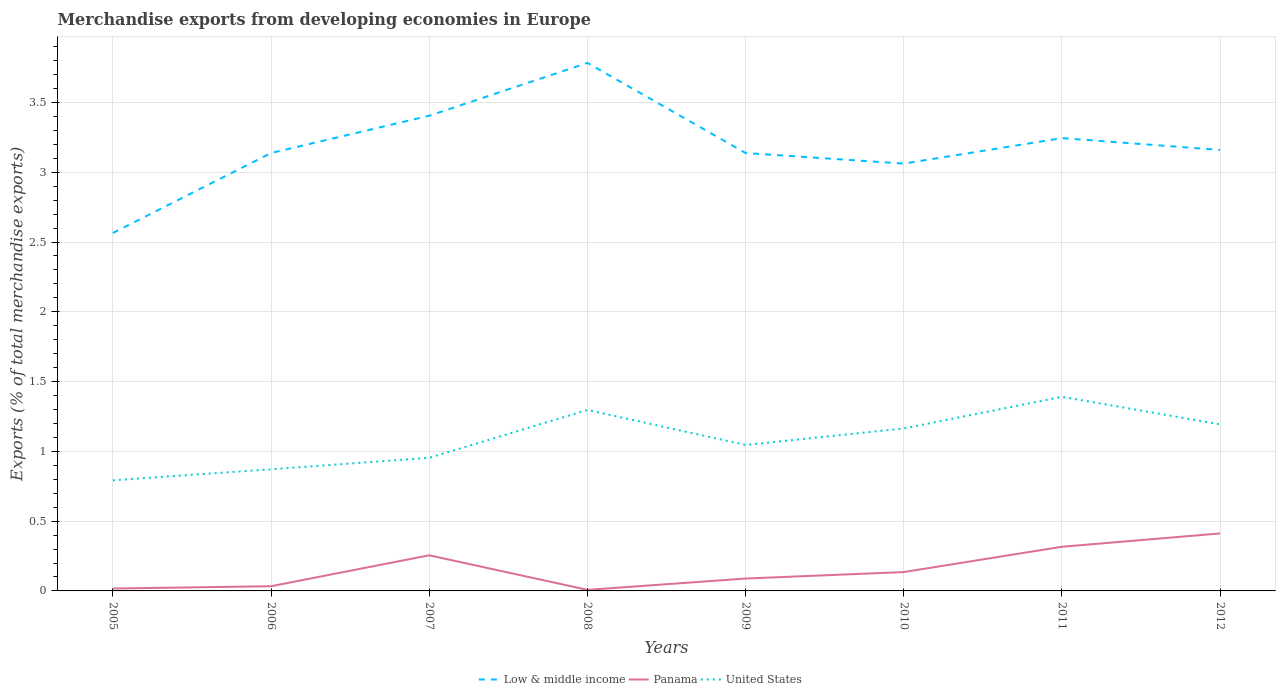How many different coloured lines are there?
Provide a short and direct response. 3. Does the line corresponding to Low & middle income intersect with the line corresponding to Panama?
Your response must be concise. No. Across all years, what is the maximum percentage of total merchandise exports in Low & middle income?
Provide a succinct answer. 2.56. What is the total percentage of total merchandise exports in United States in the graph?
Offer a terse response. -0.08. What is the difference between the highest and the second highest percentage of total merchandise exports in Panama?
Provide a succinct answer. 0.4. What is the difference between the highest and the lowest percentage of total merchandise exports in Low & middle income?
Provide a short and direct response. 3. How many years are there in the graph?
Offer a terse response. 8. Does the graph contain any zero values?
Give a very brief answer. No. Does the graph contain grids?
Your response must be concise. Yes. How many legend labels are there?
Give a very brief answer. 3. What is the title of the graph?
Offer a very short reply. Merchandise exports from developing economies in Europe. What is the label or title of the Y-axis?
Give a very brief answer. Exports (% of total merchandise exports). What is the Exports (% of total merchandise exports) in Low & middle income in 2005?
Give a very brief answer. 2.56. What is the Exports (% of total merchandise exports) in Panama in 2005?
Make the answer very short. 0.02. What is the Exports (% of total merchandise exports) in United States in 2005?
Your answer should be very brief. 0.79. What is the Exports (% of total merchandise exports) in Low & middle income in 2006?
Make the answer very short. 3.14. What is the Exports (% of total merchandise exports) in Panama in 2006?
Offer a terse response. 0.03. What is the Exports (% of total merchandise exports) in United States in 2006?
Provide a succinct answer. 0.87. What is the Exports (% of total merchandise exports) of Low & middle income in 2007?
Give a very brief answer. 3.4. What is the Exports (% of total merchandise exports) in Panama in 2007?
Give a very brief answer. 0.26. What is the Exports (% of total merchandise exports) of United States in 2007?
Your answer should be very brief. 0.95. What is the Exports (% of total merchandise exports) in Low & middle income in 2008?
Your response must be concise. 3.78. What is the Exports (% of total merchandise exports) of Panama in 2008?
Your answer should be compact. 0.01. What is the Exports (% of total merchandise exports) in United States in 2008?
Ensure brevity in your answer.  1.3. What is the Exports (% of total merchandise exports) of Low & middle income in 2009?
Ensure brevity in your answer.  3.14. What is the Exports (% of total merchandise exports) of Panama in 2009?
Give a very brief answer. 0.09. What is the Exports (% of total merchandise exports) in United States in 2009?
Offer a terse response. 1.05. What is the Exports (% of total merchandise exports) of Low & middle income in 2010?
Keep it short and to the point. 3.06. What is the Exports (% of total merchandise exports) in Panama in 2010?
Offer a very short reply. 0.14. What is the Exports (% of total merchandise exports) in United States in 2010?
Your answer should be compact. 1.16. What is the Exports (% of total merchandise exports) of Low & middle income in 2011?
Make the answer very short. 3.24. What is the Exports (% of total merchandise exports) of Panama in 2011?
Your answer should be very brief. 0.32. What is the Exports (% of total merchandise exports) of United States in 2011?
Provide a short and direct response. 1.39. What is the Exports (% of total merchandise exports) in Low & middle income in 2012?
Give a very brief answer. 3.16. What is the Exports (% of total merchandise exports) of Panama in 2012?
Your answer should be very brief. 0.41. What is the Exports (% of total merchandise exports) in United States in 2012?
Offer a terse response. 1.19. Across all years, what is the maximum Exports (% of total merchandise exports) of Low & middle income?
Provide a short and direct response. 3.78. Across all years, what is the maximum Exports (% of total merchandise exports) of Panama?
Offer a terse response. 0.41. Across all years, what is the maximum Exports (% of total merchandise exports) of United States?
Make the answer very short. 1.39. Across all years, what is the minimum Exports (% of total merchandise exports) in Low & middle income?
Provide a short and direct response. 2.56. Across all years, what is the minimum Exports (% of total merchandise exports) in Panama?
Provide a succinct answer. 0.01. Across all years, what is the minimum Exports (% of total merchandise exports) of United States?
Keep it short and to the point. 0.79. What is the total Exports (% of total merchandise exports) of Low & middle income in the graph?
Your answer should be compact. 25.49. What is the total Exports (% of total merchandise exports) of Panama in the graph?
Provide a succinct answer. 1.27. What is the total Exports (% of total merchandise exports) in United States in the graph?
Make the answer very short. 8.71. What is the difference between the Exports (% of total merchandise exports) in Low & middle income in 2005 and that in 2006?
Provide a succinct answer. -0.57. What is the difference between the Exports (% of total merchandise exports) in Panama in 2005 and that in 2006?
Give a very brief answer. -0.02. What is the difference between the Exports (% of total merchandise exports) in United States in 2005 and that in 2006?
Ensure brevity in your answer.  -0.08. What is the difference between the Exports (% of total merchandise exports) in Low & middle income in 2005 and that in 2007?
Provide a succinct answer. -0.84. What is the difference between the Exports (% of total merchandise exports) of Panama in 2005 and that in 2007?
Provide a succinct answer. -0.24. What is the difference between the Exports (% of total merchandise exports) in United States in 2005 and that in 2007?
Offer a very short reply. -0.16. What is the difference between the Exports (% of total merchandise exports) in Low & middle income in 2005 and that in 2008?
Offer a terse response. -1.22. What is the difference between the Exports (% of total merchandise exports) in Panama in 2005 and that in 2008?
Make the answer very short. 0.01. What is the difference between the Exports (% of total merchandise exports) in United States in 2005 and that in 2008?
Offer a very short reply. -0.5. What is the difference between the Exports (% of total merchandise exports) in Low & middle income in 2005 and that in 2009?
Keep it short and to the point. -0.57. What is the difference between the Exports (% of total merchandise exports) of Panama in 2005 and that in 2009?
Give a very brief answer. -0.07. What is the difference between the Exports (% of total merchandise exports) of United States in 2005 and that in 2009?
Keep it short and to the point. -0.25. What is the difference between the Exports (% of total merchandise exports) in Low & middle income in 2005 and that in 2010?
Make the answer very short. -0.5. What is the difference between the Exports (% of total merchandise exports) in Panama in 2005 and that in 2010?
Make the answer very short. -0.12. What is the difference between the Exports (% of total merchandise exports) of United States in 2005 and that in 2010?
Offer a very short reply. -0.37. What is the difference between the Exports (% of total merchandise exports) in Low & middle income in 2005 and that in 2011?
Make the answer very short. -0.68. What is the difference between the Exports (% of total merchandise exports) of Panama in 2005 and that in 2011?
Your response must be concise. -0.3. What is the difference between the Exports (% of total merchandise exports) in United States in 2005 and that in 2011?
Provide a short and direct response. -0.6. What is the difference between the Exports (% of total merchandise exports) in Low & middle income in 2005 and that in 2012?
Your answer should be compact. -0.59. What is the difference between the Exports (% of total merchandise exports) in Panama in 2005 and that in 2012?
Give a very brief answer. -0.39. What is the difference between the Exports (% of total merchandise exports) of United States in 2005 and that in 2012?
Offer a terse response. -0.4. What is the difference between the Exports (% of total merchandise exports) in Low & middle income in 2006 and that in 2007?
Provide a succinct answer. -0.27. What is the difference between the Exports (% of total merchandise exports) in Panama in 2006 and that in 2007?
Your response must be concise. -0.22. What is the difference between the Exports (% of total merchandise exports) of United States in 2006 and that in 2007?
Your answer should be compact. -0.08. What is the difference between the Exports (% of total merchandise exports) of Low & middle income in 2006 and that in 2008?
Your answer should be compact. -0.65. What is the difference between the Exports (% of total merchandise exports) in Panama in 2006 and that in 2008?
Your response must be concise. 0.03. What is the difference between the Exports (% of total merchandise exports) in United States in 2006 and that in 2008?
Make the answer very short. -0.42. What is the difference between the Exports (% of total merchandise exports) of Low & middle income in 2006 and that in 2009?
Your response must be concise. -0. What is the difference between the Exports (% of total merchandise exports) of Panama in 2006 and that in 2009?
Your answer should be very brief. -0.05. What is the difference between the Exports (% of total merchandise exports) of United States in 2006 and that in 2009?
Ensure brevity in your answer.  -0.17. What is the difference between the Exports (% of total merchandise exports) in Low & middle income in 2006 and that in 2010?
Make the answer very short. 0.08. What is the difference between the Exports (% of total merchandise exports) in Panama in 2006 and that in 2010?
Make the answer very short. -0.1. What is the difference between the Exports (% of total merchandise exports) in United States in 2006 and that in 2010?
Your answer should be compact. -0.29. What is the difference between the Exports (% of total merchandise exports) of Low & middle income in 2006 and that in 2011?
Your answer should be very brief. -0.11. What is the difference between the Exports (% of total merchandise exports) of Panama in 2006 and that in 2011?
Provide a succinct answer. -0.28. What is the difference between the Exports (% of total merchandise exports) of United States in 2006 and that in 2011?
Your answer should be very brief. -0.52. What is the difference between the Exports (% of total merchandise exports) in Low & middle income in 2006 and that in 2012?
Offer a terse response. -0.02. What is the difference between the Exports (% of total merchandise exports) in Panama in 2006 and that in 2012?
Your response must be concise. -0.38. What is the difference between the Exports (% of total merchandise exports) of United States in 2006 and that in 2012?
Ensure brevity in your answer.  -0.32. What is the difference between the Exports (% of total merchandise exports) in Low & middle income in 2007 and that in 2008?
Your response must be concise. -0.38. What is the difference between the Exports (% of total merchandise exports) in Panama in 2007 and that in 2008?
Provide a succinct answer. 0.25. What is the difference between the Exports (% of total merchandise exports) in United States in 2007 and that in 2008?
Give a very brief answer. -0.34. What is the difference between the Exports (% of total merchandise exports) in Low & middle income in 2007 and that in 2009?
Ensure brevity in your answer.  0.27. What is the difference between the Exports (% of total merchandise exports) of Panama in 2007 and that in 2009?
Provide a succinct answer. 0.17. What is the difference between the Exports (% of total merchandise exports) in United States in 2007 and that in 2009?
Offer a terse response. -0.09. What is the difference between the Exports (% of total merchandise exports) in Low & middle income in 2007 and that in 2010?
Give a very brief answer. 0.34. What is the difference between the Exports (% of total merchandise exports) of Panama in 2007 and that in 2010?
Provide a succinct answer. 0.12. What is the difference between the Exports (% of total merchandise exports) of United States in 2007 and that in 2010?
Your response must be concise. -0.21. What is the difference between the Exports (% of total merchandise exports) of Low & middle income in 2007 and that in 2011?
Offer a very short reply. 0.16. What is the difference between the Exports (% of total merchandise exports) of Panama in 2007 and that in 2011?
Offer a terse response. -0.06. What is the difference between the Exports (% of total merchandise exports) of United States in 2007 and that in 2011?
Offer a terse response. -0.44. What is the difference between the Exports (% of total merchandise exports) of Low & middle income in 2007 and that in 2012?
Provide a succinct answer. 0.24. What is the difference between the Exports (% of total merchandise exports) of Panama in 2007 and that in 2012?
Ensure brevity in your answer.  -0.16. What is the difference between the Exports (% of total merchandise exports) of United States in 2007 and that in 2012?
Your response must be concise. -0.24. What is the difference between the Exports (% of total merchandise exports) of Low & middle income in 2008 and that in 2009?
Ensure brevity in your answer.  0.65. What is the difference between the Exports (% of total merchandise exports) of Panama in 2008 and that in 2009?
Offer a very short reply. -0.08. What is the difference between the Exports (% of total merchandise exports) of United States in 2008 and that in 2009?
Provide a succinct answer. 0.25. What is the difference between the Exports (% of total merchandise exports) in Low & middle income in 2008 and that in 2010?
Offer a terse response. 0.72. What is the difference between the Exports (% of total merchandise exports) of Panama in 2008 and that in 2010?
Ensure brevity in your answer.  -0.13. What is the difference between the Exports (% of total merchandise exports) of United States in 2008 and that in 2010?
Your answer should be very brief. 0.13. What is the difference between the Exports (% of total merchandise exports) of Low & middle income in 2008 and that in 2011?
Your answer should be compact. 0.54. What is the difference between the Exports (% of total merchandise exports) of Panama in 2008 and that in 2011?
Provide a succinct answer. -0.31. What is the difference between the Exports (% of total merchandise exports) in United States in 2008 and that in 2011?
Keep it short and to the point. -0.09. What is the difference between the Exports (% of total merchandise exports) of Low & middle income in 2008 and that in 2012?
Make the answer very short. 0.62. What is the difference between the Exports (% of total merchandise exports) in Panama in 2008 and that in 2012?
Your response must be concise. -0.4. What is the difference between the Exports (% of total merchandise exports) in United States in 2008 and that in 2012?
Offer a terse response. 0.1. What is the difference between the Exports (% of total merchandise exports) in Low & middle income in 2009 and that in 2010?
Provide a short and direct response. 0.08. What is the difference between the Exports (% of total merchandise exports) of Panama in 2009 and that in 2010?
Your answer should be very brief. -0.05. What is the difference between the Exports (% of total merchandise exports) of United States in 2009 and that in 2010?
Your answer should be very brief. -0.12. What is the difference between the Exports (% of total merchandise exports) of Low & middle income in 2009 and that in 2011?
Provide a short and direct response. -0.11. What is the difference between the Exports (% of total merchandise exports) of Panama in 2009 and that in 2011?
Offer a terse response. -0.23. What is the difference between the Exports (% of total merchandise exports) in United States in 2009 and that in 2011?
Provide a short and direct response. -0.35. What is the difference between the Exports (% of total merchandise exports) in Low & middle income in 2009 and that in 2012?
Provide a short and direct response. -0.02. What is the difference between the Exports (% of total merchandise exports) of Panama in 2009 and that in 2012?
Offer a very short reply. -0.32. What is the difference between the Exports (% of total merchandise exports) of United States in 2009 and that in 2012?
Your answer should be compact. -0.15. What is the difference between the Exports (% of total merchandise exports) of Low & middle income in 2010 and that in 2011?
Your answer should be compact. -0.18. What is the difference between the Exports (% of total merchandise exports) of Panama in 2010 and that in 2011?
Ensure brevity in your answer.  -0.18. What is the difference between the Exports (% of total merchandise exports) of United States in 2010 and that in 2011?
Give a very brief answer. -0.23. What is the difference between the Exports (% of total merchandise exports) of Low & middle income in 2010 and that in 2012?
Provide a succinct answer. -0.1. What is the difference between the Exports (% of total merchandise exports) in Panama in 2010 and that in 2012?
Your response must be concise. -0.28. What is the difference between the Exports (% of total merchandise exports) in United States in 2010 and that in 2012?
Give a very brief answer. -0.03. What is the difference between the Exports (% of total merchandise exports) of Low & middle income in 2011 and that in 2012?
Make the answer very short. 0.08. What is the difference between the Exports (% of total merchandise exports) in Panama in 2011 and that in 2012?
Provide a succinct answer. -0.1. What is the difference between the Exports (% of total merchandise exports) in United States in 2011 and that in 2012?
Give a very brief answer. 0.2. What is the difference between the Exports (% of total merchandise exports) of Low & middle income in 2005 and the Exports (% of total merchandise exports) of Panama in 2006?
Your response must be concise. 2.53. What is the difference between the Exports (% of total merchandise exports) in Low & middle income in 2005 and the Exports (% of total merchandise exports) in United States in 2006?
Ensure brevity in your answer.  1.69. What is the difference between the Exports (% of total merchandise exports) in Panama in 2005 and the Exports (% of total merchandise exports) in United States in 2006?
Provide a succinct answer. -0.85. What is the difference between the Exports (% of total merchandise exports) of Low & middle income in 2005 and the Exports (% of total merchandise exports) of Panama in 2007?
Offer a terse response. 2.31. What is the difference between the Exports (% of total merchandise exports) in Low & middle income in 2005 and the Exports (% of total merchandise exports) in United States in 2007?
Offer a terse response. 1.61. What is the difference between the Exports (% of total merchandise exports) of Panama in 2005 and the Exports (% of total merchandise exports) of United States in 2007?
Your answer should be compact. -0.94. What is the difference between the Exports (% of total merchandise exports) of Low & middle income in 2005 and the Exports (% of total merchandise exports) of Panama in 2008?
Offer a terse response. 2.56. What is the difference between the Exports (% of total merchandise exports) of Low & middle income in 2005 and the Exports (% of total merchandise exports) of United States in 2008?
Provide a short and direct response. 1.27. What is the difference between the Exports (% of total merchandise exports) of Panama in 2005 and the Exports (% of total merchandise exports) of United States in 2008?
Offer a terse response. -1.28. What is the difference between the Exports (% of total merchandise exports) in Low & middle income in 2005 and the Exports (% of total merchandise exports) in Panama in 2009?
Your answer should be compact. 2.48. What is the difference between the Exports (% of total merchandise exports) in Low & middle income in 2005 and the Exports (% of total merchandise exports) in United States in 2009?
Offer a terse response. 1.52. What is the difference between the Exports (% of total merchandise exports) in Panama in 2005 and the Exports (% of total merchandise exports) in United States in 2009?
Offer a very short reply. -1.03. What is the difference between the Exports (% of total merchandise exports) in Low & middle income in 2005 and the Exports (% of total merchandise exports) in Panama in 2010?
Ensure brevity in your answer.  2.43. What is the difference between the Exports (% of total merchandise exports) in Low & middle income in 2005 and the Exports (% of total merchandise exports) in United States in 2010?
Provide a short and direct response. 1.4. What is the difference between the Exports (% of total merchandise exports) in Panama in 2005 and the Exports (% of total merchandise exports) in United States in 2010?
Your answer should be very brief. -1.15. What is the difference between the Exports (% of total merchandise exports) in Low & middle income in 2005 and the Exports (% of total merchandise exports) in Panama in 2011?
Offer a terse response. 2.25. What is the difference between the Exports (% of total merchandise exports) in Low & middle income in 2005 and the Exports (% of total merchandise exports) in United States in 2011?
Ensure brevity in your answer.  1.17. What is the difference between the Exports (% of total merchandise exports) of Panama in 2005 and the Exports (% of total merchandise exports) of United States in 2011?
Provide a succinct answer. -1.37. What is the difference between the Exports (% of total merchandise exports) of Low & middle income in 2005 and the Exports (% of total merchandise exports) of Panama in 2012?
Your answer should be very brief. 2.15. What is the difference between the Exports (% of total merchandise exports) of Low & middle income in 2005 and the Exports (% of total merchandise exports) of United States in 2012?
Give a very brief answer. 1.37. What is the difference between the Exports (% of total merchandise exports) of Panama in 2005 and the Exports (% of total merchandise exports) of United States in 2012?
Keep it short and to the point. -1.18. What is the difference between the Exports (% of total merchandise exports) in Low & middle income in 2006 and the Exports (% of total merchandise exports) in Panama in 2007?
Give a very brief answer. 2.88. What is the difference between the Exports (% of total merchandise exports) of Low & middle income in 2006 and the Exports (% of total merchandise exports) of United States in 2007?
Your response must be concise. 2.18. What is the difference between the Exports (% of total merchandise exports) in Panama in 2006 and the Exports (% of total merchandise exports) in United States in 2007?
Your answer should be compact. -0.92. What is the difference between the Exports (% of total merchandise exports) in Low & middle income in 2006 and the Exports (% of total merchandise exports) in Panama in 2008?
Give a very brief answer. 3.13. What is the difference between the Exports (% of total merchandise exports) in Low & middle income in 2006 and the Exports (% of total merchandise exports) in United States in 2008?
Provide a short and direct response. 1.84. What is the difference between the Exports (% of total merchandise exports) in Panama in 2006 and the Exports (% of total merchandise exports) in United States in 2008?
Offer a very short reply. -1.26. What is the difference between the Exports (% of total merchandise exports) in Low & middle income in 2006 and the Exports (% of total merchandise exports) in Panama in 2009?
Your response must be concise. 3.05. What is the difference between the Exports (% of total merchandise exports) in Low & middle income in 2006 and the Exports (% of total merchandise exports) in United States in 2009?
Make the answer very short. 2.09. What is the difference between the Exports (% of total merchandise exports) in Panama in 2006 and the Exports (% of total merchandise exports) in United States in 2009?
Your answer should be compact. -1.01. What is the difference between the Exports (% of total merchandise exports) in Low & middle income in 2006 and the Exports (% of total merchandise exports) in Panama in 2010?
Your answer should be very brief. 3. What is the difference between the Exports (% of total merchandise exports) in Low & middle income in 2006 and the Exports (% of total merchandise exports) in United States in 2010?
Your answer should be very brief. 1.97. What is the difference between the Exports (% of total merchandise exports) of Panama in 2006 and the Exports (% of total merchandise exports) of United States in 2010?
Your answer should be very brief. -1.13. What is the difference between the Exports (% of total merchandise exports) of Low & middle income in 2006 and the Exports (% of total merchandise exports) of Panama in 2011?
Offer a very short reply. 2.82. What is the difference between the Exports (% of total merchandise exports) of Low & middle income in 2006 and the Exports (% of total merchandise exports) of United States in 2011?
Offer a terse response. 1.75. What is the difference between the Exports (% of total merchandise exports) of Panama in 2006 and the Exports (% of total merchandise exports) of United States in 2011?
Give a very brief answer. -1.36. What is the difference between the Exports (% of total merchandise exports) of Low & middle income in 2006 and the Exports (% of total merchandise exports) of Panama in 2012?
Offer a terse response. 2.73. What is the difference between the Exports (% of total merchandise exports) in Low & middle income in 2006 and the Exports (% of total merchandise exports) in United States in 2012?
Provide a short and direct response. 1.94. What is the difference between the Exports (% of total merchandise exports) of Panama in 2006 and the Exports (% of total merchandise exports) of United States in 2012?
Provide a succinct answer. -1.16. What is the difference between the Exports (% of total merchandise exports) of Low & middle income in 2007 and the Exports (% of total merchandise exports) of Panama in 2008?
Offer a terse response. 3.4. What is the difference between the Exports (% of total merchandise exports) in Low & middle income in 2007 and the Exports (% of total merchandise exports) in United States in 2008?
Make the answer very short. 2.11. What is the difference between the Exports (% of total merchandise exports) in Panama in 2007 and the Exports (% of total merchandise exports) in United States in 2008?
Keep it short and to the point. -1.04. What is the difference between the Exports (% of total merchandise exports) in Low & middle income in 2007 and the Exports (% of total merchandise exports) in Panama in 2009?
Your answer should be compact. 3.32. What is the difference between the Exports (% of total merchandise exports) of Low & middle income in 2007 and the Exports (% of total merchandise exports) of United States in 2009?
Your response must be concise. 2.36. What is the difference between the Exports (% of total merchandise exports) in Panama in 2007 and the Exports (% of total merchandise exports) in United States in 2009?
Your answer should be compact. -0.79. What is the difference between the Exports (% of total merchandise exports) of Low & middle income in 2007 and the Exports (% of total merchandise exports) of Panama in 2010?
Provide a short and direct response. 3.27. What is the difference between the Exports (% of total merchandise exports) of Low & middle income in 2007 and the Exports (% of total merchandise exports) of United States in 2010?
Give a very brief answer. 2.24. What is the difference between the Exports (% of total merchandise exports) in Panama in 2007 and the Exports (% of total merchandise exports) in United States in 2010?
Offer a very short reply. -0.91. What is the difference between the Exports (% of total merchandise exports) of Low & middle income in 2007 and the Exports (% of total merchandise exports) of Panama in 2011?
Your answer should be very brief. 3.09. What is the difference between the Exports (% of total merchandise exports) in Low & middle income in 2007 and the Exports (% of total merchandise exports) in United States in 2011?
Keep it short and to the point. 2.01. What is the difference between the Exports (% of total merchandise exports) in Panama in 2007 and the Exports (% of total merchandise exports) in United States in 2011?
Offer a terse response. -1.14. What is the difference between the Exports (% of total merchandise exports) in Low & middle income in 2007 and the Exports (% of total merchandise exports) in Panama in 2012?
Your answer should be very brief. 2.99. What is the difference between the Exports (% of total merchandise exports) of Low & middle income in 2007 and the Exports (% of total merchandise exports) of United States in 2012?
Give a very brief answer. 2.21. What is the difference between the Exports (% of total merchandise exports) in Panama in 2007 and the Exports (% of total merchandise exports) in United States in 2012?
Your answer should be compact. -0.94. What is the difference between the Exports (% of total merchandise exports) in Low & middle income in 2008 and the Exports (% of total merchandise exports) in Panama in 2009?
Provide a succinct answer. 3.69. What is the difference between the Exports (% of total merchandise exports) in Low & middle income in 2008 and the Exports (% of total merchandise exports) in United States in 2009?
Offer a very short reply. 2.74. What is the difference between the Exports (% of total merchandise exports) of Panama in 2008 and the Exports (% of total merchandise exports) of United States in 2009?
Offer a very short reply. -1.04. What is the difference between the Exports (% of total merchandise exports) in Low & middle income in 2008 and the Exports (% of total merchandise exports) in Panama in 2010?
Offer a very short reply. 3.65. What is the difference between the Exports (% of total merchandise exports) in Low & middle income in 2008 and the Exports (% of total merchandise exports) in United States in 2010?
Your answer should be very brief. 2.62. What is the difference between the Exports (% of total merchandise exports) of Panama in 2008 and the Exports (% of total merchandise exports) of United States in 2010?
Your answer should be very brief. -1.16. What is the difference between the Exports (% of total merchandise exports) in Low & middle income in 2008 and the Exports (% of total merchandise exports) in Panama in 2011?
Offer a terse response. 3.47. What is the difference between the Exports (% of total merchandise exports) of Low & middle income in 2008 and the Exports (% of total merchandise exports) of United States in 2011?
Make the answer very short. 2.39. What is the difference between the Exports (% of total merchandise exports) in Panama in 2008 and the Exports (% of total merchandise exports) in United States in 2011?
Ensure brevity in your answer.  -1.38. What is the difference between the Exports (% of total merchandise exports) in Low & middle income in 2008 and the Exports (% of total merchandise exports) in Panama in 2012?
Your answer should be compact. 3.37. What is the difference between the Exports (% of total merchandise exports) of Low & middle income in 2008 and the Exports (% of total merchandise exports) of United States in 2012?
Your answer should be compact. 2.59. What is the difference between the Exports (% of total merchandise exports) in Panama in 2008 and the Exports (% of total merchandise exports) in United States in 2012?
Your answer should be compact. -1.19. What is the difference between the Exports (% of total merchandise exports) in Low & middle income in 2009 and the Exports (% of total merchandise exports) in Panama in 2010?
Your response must be concise. 3. What is the difference between the Exports (% of total merchandise exports) in Low & middle income in 2009 and the Exports (% of total merchandise exports) in United States in 2010?
Give a very brief answer. 1.97. What is the difference between the Exports (% of total merchandise exports) in Panama in 2009 and the Exports (% of total merchandise exports) in United States in 2010?
Offer a terse response. -1.08. What is the difference between the Exports (% of total merchandise exports) of Low & middle income in 2009 and the Exports (% of total merchandise exports) of Panama in 2011?
Offer a very short reply. 2.82. What is the difference between the Exports (% of total merchandise exports) of Low & middle income in 2009 and the Exports (% of total merchandise exports) of United States in 2011?
Provide a succinct answer. 1.75. What is the difference between the Exports (% of total merchandise exports) of Panama in 2009 and the Exports (% of total merchandise exports) of United States in 2011?
Provide a short and direct response. -1.3. What is the difference between the Exports (% of total merchandise exports) of Low & middle income in 2009 and the Exports (% of total merchandise exports) of Panama in 2012?
Ensure brevity in your answer.  2.73. What is the difference between the Exports (% of total merchandise exports) of Low & middle income in 2009 and the Exports (% of total merchandise exports) of United States in 2012?
Keep it short and to the point. 1.94. What is the difference between the Exports (% of total merchandise exports) in Panama in 2009 and the Exports (% of total merchandise exports) in United States in 2012?
Provide a short and direct response. -1.1. What is the difference between the Exports (% of total merchandise exports) in Low & middle income in 2010 and the Exports (% of total merchandise exports) in Panama in 2011?
Make the answer very short. 2.75. What is the difference between the Exports (% of total merchandise exports) of Low & middle income in 2010 and the Exports (% of total merchandise exports) of United States in 2011?
Provide a short and direct response. 1.67. What is the difference between the Exports (% of total merchandise exports) of Panama in 2010 and the Exports (% of total merchandise exports) of United States in 2011?
Keep it short and to the point. -1.26. What is the difference between the Exports (% of total merchandise exports) in Low & middle income in 2010 and the Exports (% of total merchandise exports) in Panama in 2012?
Ensure brevity in your answer.  2.65. What is the difference between the Exports (% of total merchandise exports) of Low & middle income in 2010 and the Exports (% of total merchandise exports) of United States in 2012?
Offer a very short reply. 1.87. What is the difference between the Exports (% of total merchandise exports) in Panama in 2010 and the Exports (% of total merchandise exports) in United States in 2012?
Keep it short and to the point. -1.06. What is the difference between the Exports (% of total merchandise exports) in Low & middle income in 2011 and the Exports (% of total merchandise exports) in Panama in 2012?
Provide a succinct answer. 2.83. What is the difference between the Exports (% of total merchandise exports) in Low & middle income in 2011 and the Exports (% of total merchandise exports) in United States in 2012?
Provide a short and direct response. 2.05. What is the difference between the Exports (% of total merchandise exports) in Panama in 2011 and the Exports (% of total merchandise exports) in United States in 2012?
Ensure brevity in your answer.  -0.88. What is the average Exports (% of total merchandise exports) in Low & middle income per year?
Your answer should be very brief. 3.19. What is the average Exports (% of total merchandise exports) in Panama per year?
Offer a very short reply. 0.16. What is the average Exports (% of total merchandise exports) of United States per year?
Offer a terse response. 1.09. In the year 2005, what is the difference between the Exports (% of total merchandise exports) in Low & middle income and Exports (% of total merchandise exports) in Panama?
Keep it short and to the point. 2.55. In the year 2005, what is the difference between the Exports (% of total merchandise exports) in Low & middle income and Exports (% of total merchandise exports) in United States?
Make the answer very short. 1.77. In the year 2005, what is the difference between the Exports (% of total merchandise exports) of Panama and Exports (% of total merchandise exports) of United States?
Your answer should be very brief. -0.78. In the year 2006, what is the difference between the Exports (% of total merchandise exports) of Low & middle income and Exports (% of total merchandise exports) of Panama?
Your answer should be compact. 3.1. In the year 2006, what is the difference between the Exports (% of total merchandise exports) of Low & middle income and Exports (% of total merchandise exports) of United States?
Give a very brief answer. 2.27. In the year 2006, what is the difference between the Exports (% of total merchandise exports) of Panama and Exports (% of total merchandise exports) of United States?
Offer a terse response. -0.84. In the year 2007, what is the difference between the Exports (% of total merchandise exports) in Low & middle income and Exports (% of total merchandise exports) in Panama?
Ensure brevity in your answer.  3.15. In the year 2007, what is the difference between the Exports (% of total merchandise exports) of Low & middle income and Exports (% of total merchandise exports) of United States?
Keep it short and to the point. 2.45. In the year 2007, what is the difference between the Exports (% of total merchandise exports) of Panama and Exports (% of total merchandise exports) of United States?
Ensure brevity in your answer.  -0.7. In the year 2008, what is the difference between the Exports (% of total merchandise exports) in Low & middle income and Exports (% of total merchandise exports) in Panama?
Provide a short and direct response. 3.78. In the year 2008, what is the difference between the Exports (% of total merchandise exports) in Low & middle income and Exports (% of total merchandise exports) in United States?
Your answer should be compact. 2.49. In the year 2008, what is the difference between the Exports (% of total merchandise exports) of Panama and Exports (% of total merchandise exports) of United States?
Your response must be concise. -1.29. In the year 2009, what is the difference between the Exports (% of total merchandise exports) of Low & middle income and Exports (% of total merchandise exports) of Panama?
Keep it short and to the point. 3.05. In the year 2009, what is the difference between the Exports (% of total merchandise exports) in Low & middle income and Exports (% of total merchandise exports) in United States?
Ensure brevity in your answer.  2.09. In the year 2009, what is the difference between the Exports (% of total merchandise exports) of Panama and Exports (% of total merchandise exports) of United States?
Give a very brief answer. -0.96. In the year 2010, what is the difference between the Exports (% of total merchandise exports) in Low & middle income and Exports (% of total merchandise exports) in Panama?
Give a very brief answer. 2.93. In the year 2010, what is the difference between the Exports (% of total merchandise exports) in Low & middle income and Exports (% of total merchandise exports) in United States?
Make the answer very short. 1.9. In the year 2010, what is the difference between the Exports (% of total merchandise exports) of Panama and Exports (% of total merchandise exports) of United States?
Offer a very short reply. -1.03. In the year 2011, what is the difference between the Exports (% of total merchandise exports) of Low & middle income and Exports (% of total merchandise exports) of Panama?
Your answer should be very brief. 2.93. In the year 2011, what is the difference between the Exports (% of total merchandise exports) in Low & middle income and Exports (% of total merchandise exports) in United States?
Make the answer very short. 1.85. In the year 2011, what is the difference between the Exports (% of total merchandise exports) of Panama and Exports (% of total merchandise exports) of United States?
Provide a succinct answer. -1.07. In the year 2012, what is the difference between the Exports (% of total merchandise exports) in Low & middle income and Exports (% of total merchandise exports) in Panama?
Provide a succinct answer. 2.75. In the year 2012, what is the difference between the Exports (% of total merchandise exports) in Low & middle income and Exports (% of total merchandise exports) in United States?
Ensure brevity in your answer.  1.97. In the year 2012, what is the difference between the Exports (% of total merchandise exports) of Panama and Exports (% of total merchandise exports) of United States?
Offer a terse response. -0.78. What is the ratio of the Exports (% of total merchandise exports) in Low & middle income in 2005 to that in 2006?
Keep it short and to the point. 0.82. What is the ratio of the Exports (% of total merchandise exports) of Panama in 2005 to that in 2006?
Give a very brief answer. 0.51. What is the ratio of the Exports (% of total merchandise exports) of United States in 2005 to that in 2006?
Your response must be concise. 0.91. What is the ratio of the Exports (% of total merchandise exports) in Low & middle income in 2005 to that in 2007?
Your answer should be very brief. 0.75. What is the ratio of the Exports (% of total merchandise exports) of Panama in 2005 to that in 2007?
Your response must be concise. 0.07. What is the ratio of the Exports (% of total merchandise exports) in United States in 2005 to that in 2007?
Ensure brevity in your answer.  0.83. What is the ratio of the Exports (% of total merchandise exports) in Low & middle income in 2005 to that in 2008?
Offer a very short reply. 0.68. What is the ratio of the Exports (% of total merchandise exports) of Panama in 2005 to that in 2008?
Give a very brief answer. 2.24. What is the ratio of the Exports (% of total merchandise exports) of United States in 2005 to that in 2008?
Your answer should be very brief. 0.61. What is the ratio of the Exports (% of total merchandise exports) of Low & middle income in 2005 to that in 2009?
Provide a short and direct response. 0.82. What is the ratio of the Exports (% of total merchandise exports) in Panama in 2005 to that in 2009?
Ensure brevity in your answer.  0.19. What is the ratio of the Exports (% of total merchandise exports) in United States in 2005 to that in 2009?
Keep it short and to the point. 0.76. What is the ratio of the Exports (% of total merchandise exports) in Low & middle income in 2005 to that in 2010?
Your answer should be very brief. 0.84. What is the ratio of the Exports (% of total merchandise exports) in Panama in 2005 to that in 2010?
Make the answer very short. 0.13. What is the ratio of the Exports (% of total merchandise exports) in United States in 2005 to that in 2010?
Ensure brevity in your answer.  0.68. What is the ratio of the Exports (% of total merchandise exports) in Low & middle income in 2005 to that in 2011?
Give a very brief answer. 0.79. What is the ratio of the Exports (% of total merchandise exports) in Panama in 2005 to that in 2011?
Offer a very short reply. 0.05. What is the ratio of the Exports (% of total merchandise exports) of United States in 2005 to that in 2011?
Provide a succinct answer. 0.57. What is the ratio of the Exports (% of total merchandise exports) of Low & middle income in 2005 to that in 2012?
Provide a succinct answer. 0.81. What is the ratio of the Exports (% of total merchandise exports) of Panama in 2005 to that in 2012?
Your answer should be very brief. 0.04. What is the ratio of the Exports (% of total merchandise exports) of United States in 2005 to that in 2012?
Make the answer very short. 0.66. What is the ratio of the Exports (% of total merchandise exports) of Low & middle income in 2006 to that in 2007?
Ensure brevity in your answer.  0.92. What is the ratio of the Exports (% of total merchandise exports) in Panama in 2006 to that in 2007?
Ensure brevity in your answer.  0.13. What is the ratio of the Exports (% of total merchandise exports) in United States in 2006 to that in 2007?
Your answer should be compact. 0.91. What is the ratio of the Exports (% of total merchandise exports) of Low & middle income in 2006 to that in 2008?
Offer a very short reply. 0.83. What is the ratio of the Exports (% of total merchandise exports) in Panama in 2006 to that in 2008?
Your answer should be compact. 4.42. What is the ratio of the Exports (% of total merchandise exports) of United States in 2006 to that in 2008?
Provide a short and direct response. 0.67. What is the ratio of the Exports (% of total merchandise exports) of Low & middle income in 2006 to that in 2009?
Your answer should be very brief. 1. What is the ratio of the Exports (% of total merchandise exports) of Panama in 2006 to that in 2009?
Give a very brief answer. 0.38. What is the ratio of the Exports (% of total merchandise exports) in United States in 2006 to that in 2009?
Give a very brief answer. 0.83. What is the ratio of the Exports (% of total merchandise exports) in Low & middle income in 2006 to that in 2010?
Offer a very short reply. 1.02. What is the ratio of the Exports (% of total merchandise exports) of Panama in 2006 to that in 2010?
Your answer should be compact. 0.25. What is the ratio of the Exports (% of total merchandise exports) in United States in 2006 to that in 2010?
Your answer should be compact. 0.75. What is the ratio of the Exports (% of total merchandise exports) in Low & middle income in 2006 to that in 2011?
Give a very brief answer. 0.97. What is the ratio of the Exports (% of total merchandise exports) of Panama in 2006 to that in 2011?
Your response must be concise. 0.11. What is the ratio of the Exports (% of total merchandise exports) of United States in 2006 to that in 2011?
Provide a succinct answer. 0.63. What is the ratio of the Exports (% of total merchandise exports) of Low & middle income in 2006 to that in 2012?
Your response must be concise. 0.99. What is the ratio of the Exports (% of total merchandise exports) in Panama in 2006 to that in 2012?
Your answer should be compact. 0.08. What is the ratio of the Exports (% of total merchandise exports) of United States in 2006 to that in 2012?
Provide a short and direct response. 0.73. What is the ratio of the Exports (% of total merchandise exports) of Panama in 2007 to that in 2008?
Offer a very short reply. 33.42. What is the ratio of the Exports (% of total merchandise exports) in United States in 2007 to that in 2008?
Provide a succinct answer. 0.74. What is the ratio of the Exports (% of total merchandise exports) in Low & middle income in 2007 to that in 2009?
Your answer should be very brief. 1.09. What is the ratio of the Exports (% of total merchandise exports) in Panama in 2007 to that in 2009?
Your answer should be very brief. 2.88. What is the ratio of the Exports (% of total merchandise exports) in United States in 2007 to that in 2009?
Offer a terse response. 0.91. What is the ratio of the Exports (% of total merchandise exports) of Low & middle income in 2007 to that in 2010?
Offer a terse response. 1.11. What is the ratio of the Exports (% of total merchandise exports) in Panama in 2007 to that in 2010?
Provide a succinct answer. 1.89. What is the ratio of the Exports (% of total merchandise exports) of United States in 2007 to that in 2010?
Keep it short and to the point. 0.82. What is the ratio of the Exports (% of total merchandise exports) in Low & middle income in 2007 to that in 2011?
Provide a succinct answer. 1.05. What is the ratio of the Exports (% of total merchandise exports) of Panama in 2007 to that in 2011?
Give a very brief answer. 0.81. What is the ratio of the Exports (% of total merchandise exports) of United States in 2007 to that in 2011?
Keep it short and to the point. 0.69. What is the ratio of the Exports (% of total merchandise exports) of Low & middle income in 2007 to that in 2012?
Offer a very short reply. 1.08. What is the ratio of the Exports (% of total merchandise exports) of Panama in 2007 to that in 2012?
Keep it short and to the point. 0.62. What is the ratio of the Exports (% of total merchandise exports) in United States in 2007 to that in 2012?
Make the answer very short. 0.8. What is the ratio of the Exports (% of total merchandise exports) in Low & middle income in 2008 to that in 2009?
Your response must be concise. 1.21. What is the ratio of the Exports (% of total merchandise exports) of Panama in 2008 to that in 2009?
Your response must be concise. 0.09. What is the ratio of the Exports (% of total merchandise exports) of United States in 2008 to that in 2009?
Keep it short and to the point. 1.24. What is the ratio of the Exports (% of total merchandise exports) of Low & middle income in 2008 to that in 2010?
Your response must be concise. 1.24. What is the ratio of the Exports (% of total merchandise exports) in Panama in 2008 to that in 2010?
Make the answer very short. 0.06. What is the ratio of the Exports (% of total merchandise exports) in United States in 2008 to that in 2010?
Your answer should be compact. 1.11. What is the ratio of the Exports (% of total merchandise exports) in Low & middle income in 2008 to that in 2011?
Ensure brevity in your answer.  1.17. What is the ratio of the Exports (% of total merchandise exports) in Panama in 2008 to that in 2011?
Your answer should be compact. 0.02. What is the ratio of the Exports (% of total merchandise exports) in United States in 2008 to that in 2011?
Provide a short and direct response. 0.93. What is the ratio of the Exports (% of total merchandise exports) in Low & middle income in 2008 to that in 2012?
Your response must be concise. 1.2. What is the ratio of the Exports (% of total merchandise exports) in Panama in 2008 to that in 2012?
Give a very brief answer. 0.02. What is the ratio of the Exports (% of total merchandise exports) of United States in 2008 to that in 2012?
Offer a very short reply. 1.09. What is the ratio of the Exports (% of total merchandise exports) of Low & middle income in 2009 to that in 2010?
Make the answer very short. 1.02. What is the ratio of the Exports (% of total merchandise exports) of Panama in 2009 to that in 2010?
Give a very brief answer. 0.66. What is the ratio of the Exports (% of total merchandise exports) of United States in 2009 to that in 2010?
Your answer should be compact. 0.9. What is the ratio of the Exports (% of total merchandise exports) in Low & middle income in 2009 to that in 2011?
Offer a terse response. 0.97. What is the ratio of the Exports (% of total merchandise exports) in Panama in 2009 to that in 2011?
Make the answer very short. 0.28. What is the ratio of the Exports (% of total merchandise exports) of United States in 2009 to that in 2011?
Provide a succinct answer. 0.75. What is the ratio of the Exports (% of total merchandise exports) in Low & middle income in 2009 to that in 2012?
Keep it short and to the point. 0.99. What is the ratio of the Exports (% of total merchandise exports) of Panama in 2009 to that in 2012?
Your response must be concise. 0.22. What is the ratio of the Exports (% of total merchandise exports) in United States in 2009 to that in 2012?
Ensure brevity in your answer.  0.88. What is the ratio of the Exports (% of total merchandise exports) of Low & middle income in 2010 to that in 2011?
Give a very brief answer. 0.94. What is the ratio of the Exports (% of total merchandise exports) of Panama in 2010 to that in 2011?
Your response must be concise. 0.43. What is the ratio of the Exports (% of total merchandise exports) in United States in 2010 to that in 2011?
Your response must be concise. 0.84. What is the ratio of the Exports (% of total merchandise exports) of Panama in 2010 to that in 2012?
Provide a succinct answer. 0.33. What is the ratio of the Exports (% of total merchandise exports) of United States in 2010 to that in 2012?
Give a very brief answer. 0.98. What is the ratio of the Exports (% of total merchandise exports) of Low & middle income in 2011 to that in 2012?
Ensure brevity in your answer.  1.03. What is the ratio of the Exports (% of total merchandise exports) of Panama in 2011 to that in 2012?
Offer a very short reply. 0.77. What is the ratio of the Exports (% of total merchandise exports) in United States in 2011 to that in 2012?
Your answer should be very brief. 1.17. What is the difference between the highest and the second highest Exports (% of total merchandise exports) in Low & middle income?
Offer a very short reply. 0.38. What is the difference between the highest and the second highest Exports (% of total merchandise exports) of Panama?
Your answer should be compact. 0.1. What is the difference between the highest and the second highest Exports (% of total merchandise exports) in United States?
Your answer should be very brief. 0.09. What is the difference between the highest and the lowest Exports (% of total merchandise exports) in Low & middle income?
Your response must be concise. 1.22. What is the difference between the highest and the lowest Exports (% of total merchandise exports) in Panama?
Provide a short and direct response. 0.4. What is the difference between the highest and the lowest Exports (% of total merchandise exports) in United States?
Your response must be concise. 0.6. 